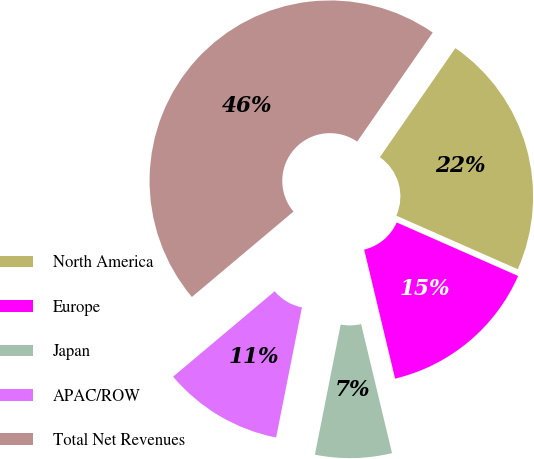Convert chart to OTSL. <chart><loc_0><loc_0><loc_500><loc_500><pie_chart><fcel>North America<fcel>Europe<fcel>Japan<fcel>APAC/ROW<fcel>Total Net Revenues<nl><fcel>21.97%<fcel>14.65%<fcel>6.86%<fcel>10.76%<fcel>45.77%<nl></chart> 